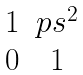<formula> <loc_0><loc_0><loc_500><loc_500>\begin{matrix} 1 & p s ^ { 2 } \\ 0 & 1 \end{matrix}</formula> 